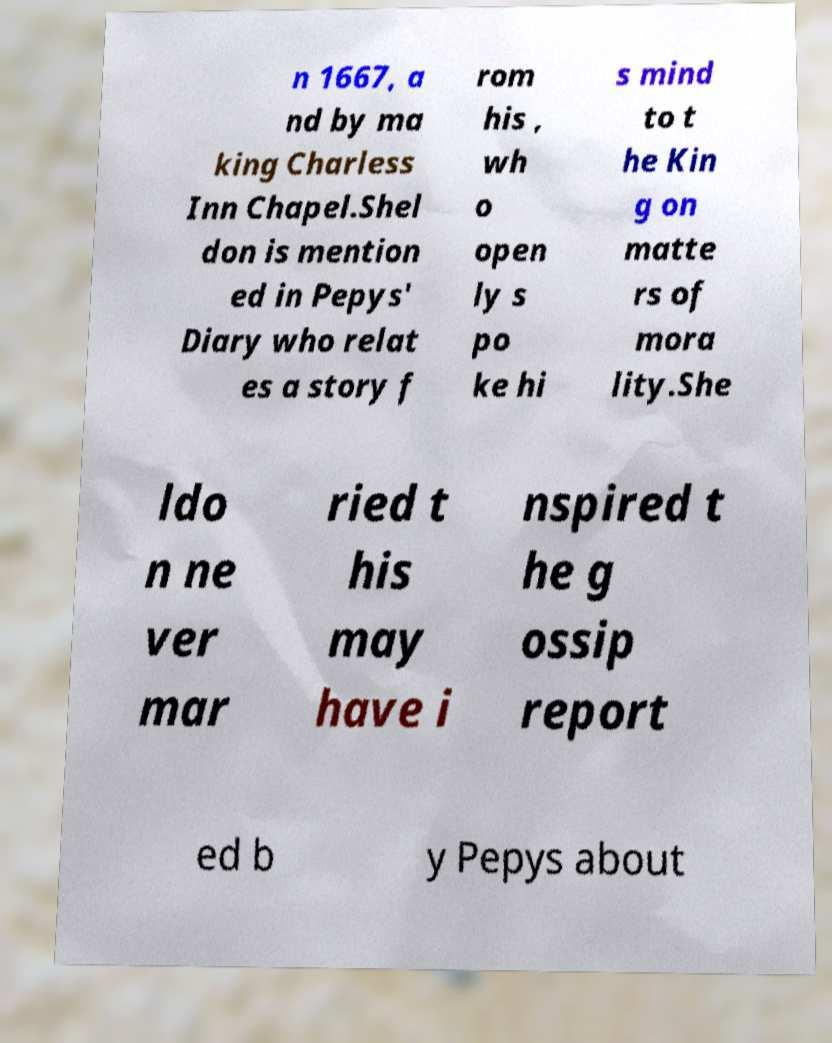Can you read and provide the text displayed in the image?This photo seems to have some interesting text. Can you extract and type it out for me? n 1667, a nd by ma king Charless Inn Chapel.Shel don is mention ed in Pepys' Diary who relat es a story f rom his , wh o open ly s po ke hi s mind to t he Kin g on matte rs of mora lity.She ldo n ne ver mar ried t his may have i nspired t he g ossip report ed b y Pepys about 